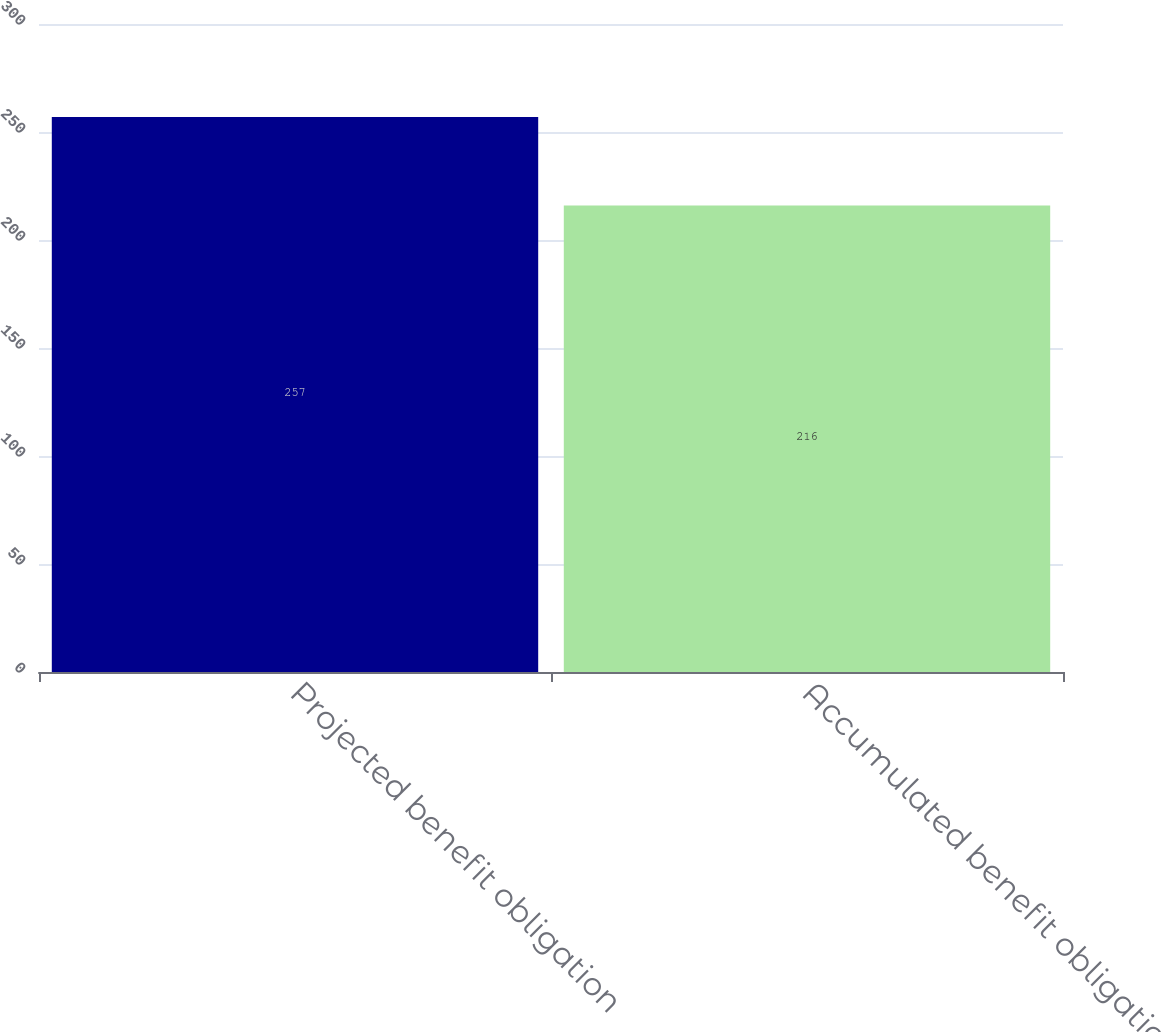<chart> <loc_0><loc_0><loc_500><loc_500><bar_chart><fcel>Projected benefit obligation<fcel>Accumulated benefit obligation<nl><fcel>257<fcel>216<nl></chart> 